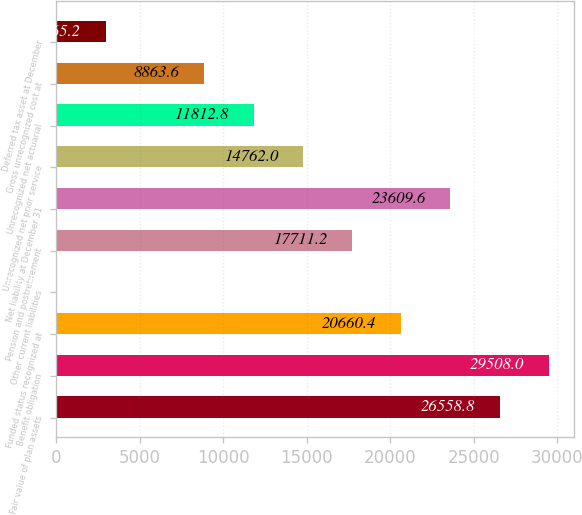<chart> <loc_0><loc_0><loc_500><loc_500><bar_chart><fcel>Fair value of plan assets<fcel>Benefit obligation<fcel>Funded status recognized at<fcel>Other current liabilities<fcel>Pension and postretirement<fcel>Net liability at December 31<fcel>Unrecognized net prior service<fcel>Unrecognized net actuarial<fcel>Gross unrecognized cost at<fcel>Deferred tax asset at December<nl><fcel>26558.8<fcel>29508<fcel>20660.4<fcel>16<fcel>17711.2<fcel>23609.6<fcel>14762<fcel>11812.8<fcel>8863.6<fcel>2965.2<nl></chart> 